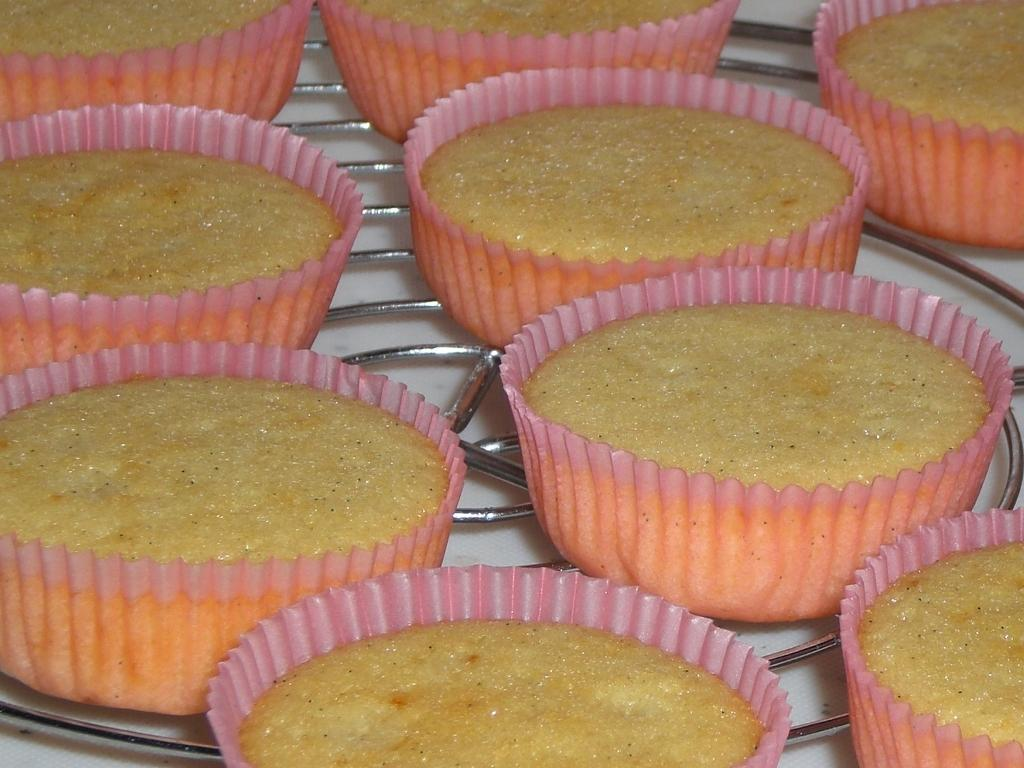What type of food can be seen in the image? There is a group of muffins in the image. Where are the muffins located? The muffins are placed on a surface. What type of house is depicted in the image? There is no house depicted in the image; it features a group of muffins placed on a surface. What suggestion does the queen make in the image? There is no queen or suggestion present in the image. 